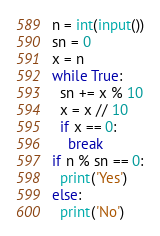Convert code to text. <code><loc_0><loc_0><loc_500><loc_500><_Python_>n = int(input())
sn = 0
x = n
while True:
  sn += x % 10
  x = x // 10
  if x == 0:
    break
if n % sn == 0:
  print('Yes')
else:
  print('No')</code> 